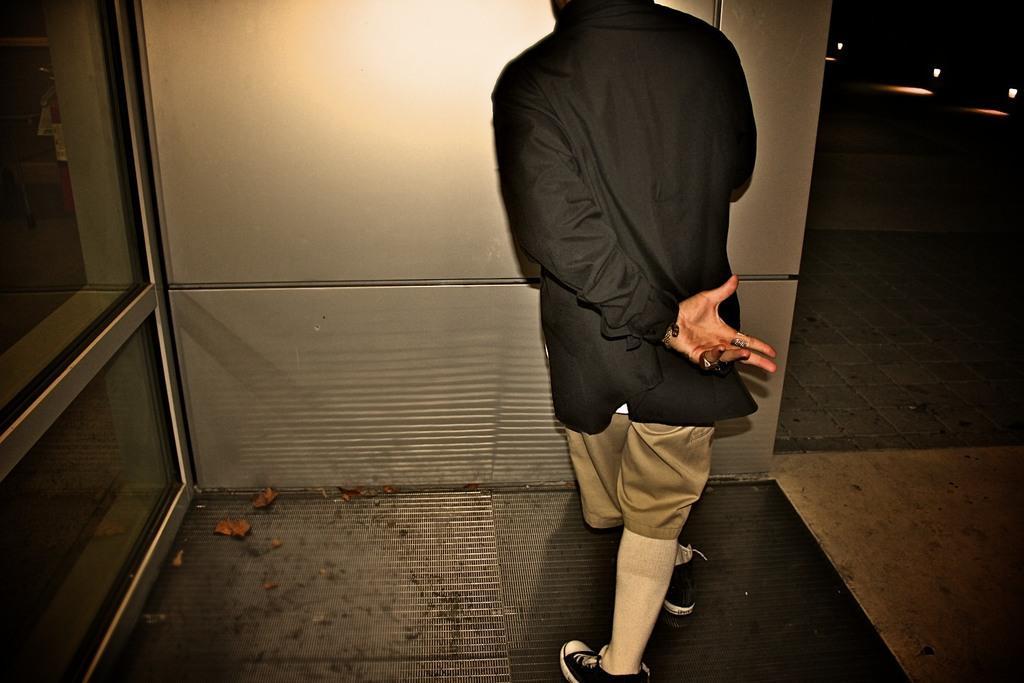In one or two sentences, can you explain what this image depicts? In this picture we can observe a person wearing black color shirt. He is standing on the floor. On the right side we can observe three lights. There is a wall in front of him. 